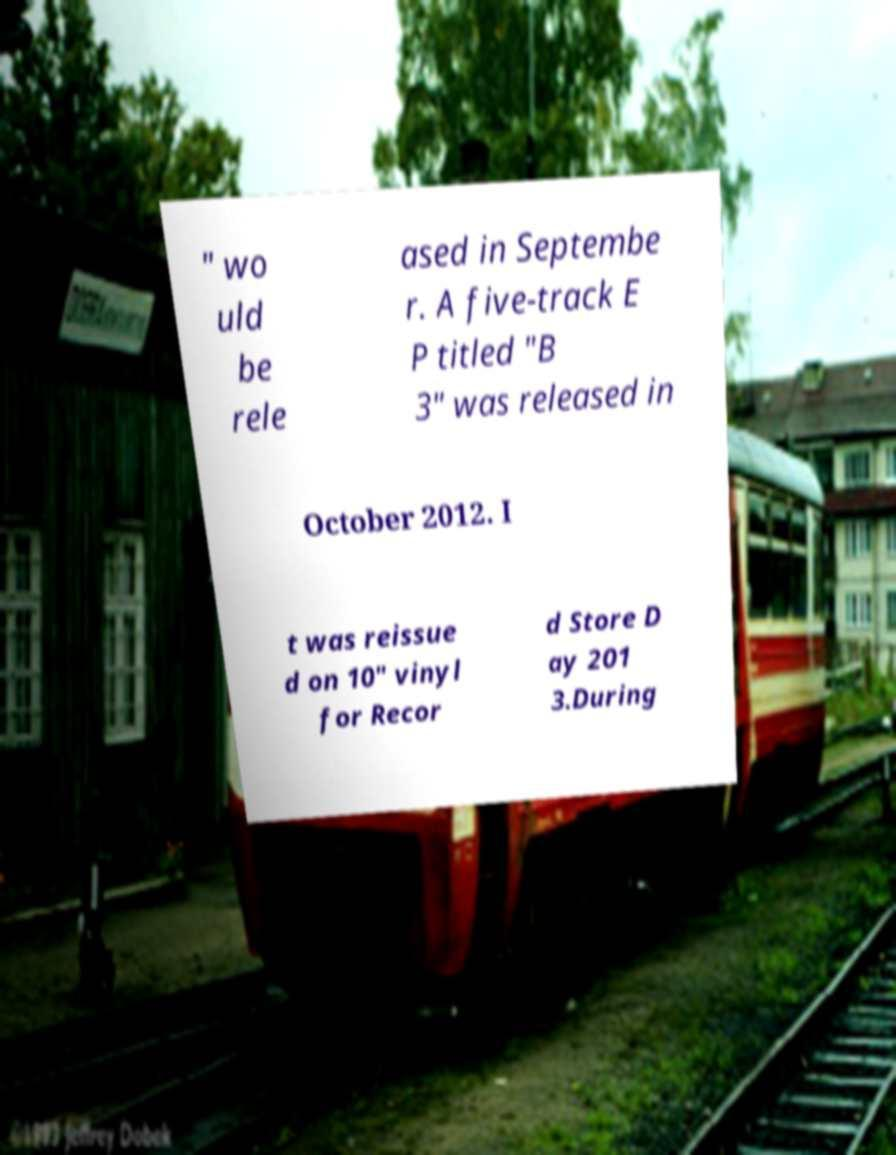Please identify and transcribe the text found in this image. " wo uld be rele ased in Septembe r. A five-track E P titled "B 3" was released in October 2012. I t was reissue d on 10" vinyl for Recor d Store D ay 201 3.During 